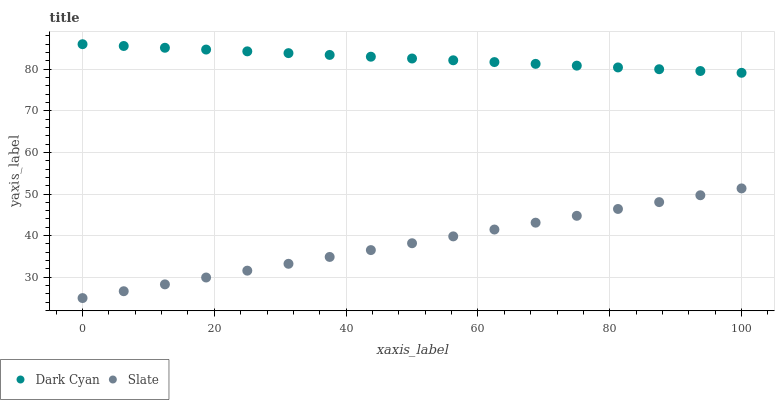Does Slate have the minimum area under the curve?
Answer yes or no. Yes. Does Dark Cyan have the maximum area under the curve?
Answer yes or no. Yes. Does Slate have the maximum area under the curve?
Answer yes or no. No. Is Slate the smoothest?
Answer yes or no. Yes. Is Dark Cyan the roughest?
Answer yes or no. Yes. Is Slate the roughest?
Answer yes or no. No. Does Slate have the lowest value?
Answer yes or no. Yes. Does Dark Cyan have the highest value?
Answer yes or no. Yes. Does Slate have the highest value?
Answer yes or no. No. Is Slate less than Dark Cyan?
Answer yes or no. Yes. Is Dark Cyan greater than Slate?
Answer yes or no. Yes. Does Slate intersect Dark Cyan?
Answer yes or no. No. 